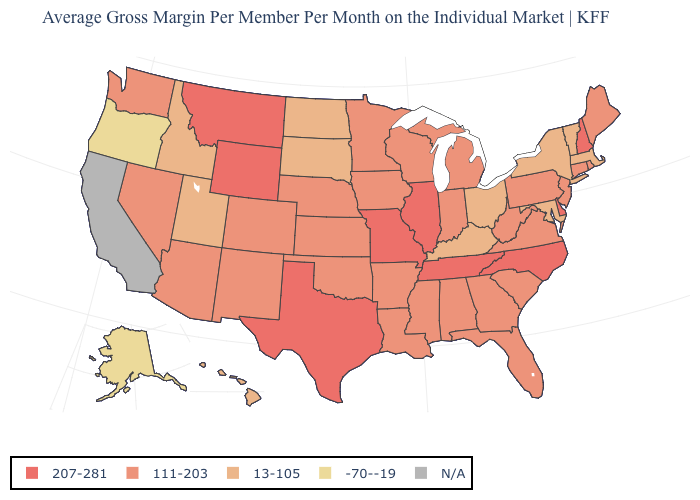What is the highest value in the USA?
Short answer required. 207-281. What is the value of Wisconsin?
Be succinct. 111-203. Name the states that have a value in the range -70--19?
Quick response, please. Alaska, Oregon. What is the value of Montana?
Be succinct. 207-281. Does Pennsylvania have the lowest value in the USA?
Be succinct. No. How many symbols are there in the legend?
Keep it brief. 5. What is the value of Minnesota?
Concise answer only. 111-203. Does South Carolina have the lowest value in the USA?
Be succinct. No. Name the states that have a value in the range N/A?
Keep it brief. California. Does Montana have the highest value in the West?
Be succinct. Yes. Which states have the lowest value in the USA?
Quick response, please. Alaska, Oregon. Which states have the highest value in the USA?
Keep it brief. Delaware, Illinois, Missouri, Montana, New Hampshire, North Carolina, Tennessee, Texas, Wyoming. Does Illinois have the highest value in the MidWest?
Concise answer only. Yes. Does Illinois have the highest value in the MidWest?
Quick response, please. Yes. 